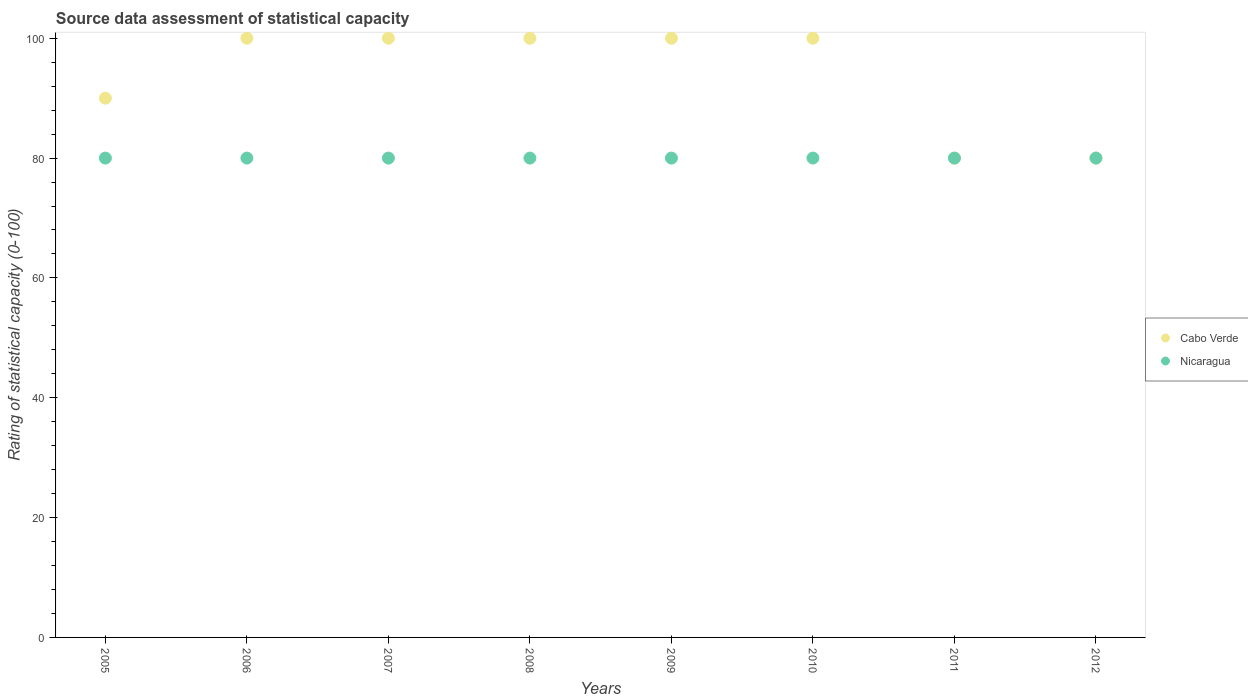Is the number of dotlines equal to the number of legend labels?
Ensure brevity in your answer.  Yes. What is the rating of statistical capacity in Cabo Verde in 2011?
Provide a succinct answer. 80. Across all years, what is the maximum rating of statistical capacity in Nicaragua?
Offer a terse response. 80. Across all years, what is the minimum rating of statistical capacity in Nicaragua?
Keep it short and to the point. 80. What is the total rating of statistical capacity in Cabo Verde in the graph?
Your response must be concise. 750. What is the difference between the rating of statistical capacity in Nicaragua in 2007 and that in 2008?
Keep it short and to the point. 0. What is the difference between the rating of statistical capacity in Nicaragua in 2005 and the rating of statistical capacity in Cabo Verde in 2008?
Make the answer very short. -20. What is the average rating of statistical capacity in Cabo Verde per year?
Offer a very short reply. 93.75. In the year 2007, what is the difference between the rating of statistical capacity in Nicaragua and rating of statistical capacity in Cabo Verde?
Your answer should be compact. -20. In how many years, is the rating of statistical capacity in Nicaragua greater than 28?
Provide a succinct answer. 8. What is the ratio of the rating of statistical capacity in Nicaragua in 2010 to that in 2012?
Give a very brief answer. 1. In how many years, is the rating of statistical capacity in Cabo Verde greater than the average rating of statistical capacity in Cabo Verde taken over all years?
Your response must be concise. 5. Is the sum of the rating of statistical capacity in Cabo Verde in 2008 and 2009 greater than the maximum rating of statistical capacity in Nicaragua across all years?
Your answer should be very brief. Yes. Is the rating of statistical capacity in Nicaragua strictly less than the rating of statistical capacity in Cabo Verde over the years?
Your answer should be very brief. No. How many years are there in the graph?
Your answer should be very brief. 8. What is the difference between two consecutive major ticks on the Y-axis?
Your answer should be compact. 20. Does the graph contain any zero values?
Offer a terse response. No. Does the graph contain grids?
Provide a succinct answer. No. Where does the legend appear in the graph?
Give a very brief answer. Center right. How many legend labels are there?
Offer a very short reply. 2. How are the legend labels stacked?
Give a very brief answer. Vertical. What is the title of the graph?
Provide a short and direct response. Source data assessment of statistical capacity. What is the label or title of the X-axis?
Your answer should be very brief. Years. What is the label or title of the Y-axis?
Give a very brief answer. Rating of statistical capacity (0-100). What is the Rating of statistical capacity (0-100) of Nicaragua in 2005?
Offer a terse response. 80. What is the Rating of statistical capacity (0-100) of Cabo Verde in 2006?
Keep it short and to the point. 100. What is the Rating of statistical capacity (0-100) of Nicaragua in 2007?
Your answer should be very brief. 80. What is the Rating of statistical capacity (0-100) in Nicaragua in 2008?
Your response must be concise. 80. What is the Rating of statistical capacity (0-100) of Nicaragua in 2009?
Provide a succinct answer. 80. What is the Rating of statistical capacity (0-100) of Cabo Verde in 2010?
Give a very brief answer. 100. What is the Rating of statistical capacity (0-100) in Nicaragua in 2010?
Your response must be concise. 80. What is the Rating of statistical capacity (0-100) of Cabo Verde in 2011?
Keep it short and to the point. 80. What is the Rating of statistical capacity (0-100) in Cabo Verde in 2012?
Offer a very short reply. 80. What is the Rating of statistical capacity (0-100) of Nicaragua in 2012?
Offer a very short reply. 80. Across all years, what is the maximum Rating of statistical capacity (0-100) in Cabo Verde?
Make the answer very short. 100. Across all years, what is the maximum Rating of statistical capacity (0-100) in Nicaragua?
Keep it short and to the point. 80. What is the total Rating of statistical capacity (0-100) in Cabo Verde in the graph?
Your response must be concise. 750. What is the total Rating of statistical capacity (0-100) of Nicaragua in the graph?
Ensure brevity in your answer.  640. What is the difference between the Rating of statistical capacity (0-100) in Cabo Verde in 2005 and that in 2006?
Ensure brevity in your answer.  -10. What is the difference between the Rating of statistical capacity (0-100) in Nicaragua in 2005 and that in 2006?
Provide a short and direct response. 0. What is the difference between the Rating of statistical capacity (0-100) of Cabo Verde in 2005 and that in 2007?
Your answer should be compact. -10. What is the difference between the Rating of statistical capacity (0-100) of Nicaragua in 2005 and that in 2008?
Your response must be concise. 0. What is the difference between the Rating of statistical capacity (0-100) in Nicaragua in 2005 and that in 2010?
Ensure brevity in your answer.  0. What is the difference between the Rating of statistical capacity (0-100) in Nicaragua in 2005 and that in 2011?
Provide a short and direct response. 0. What is the difference between the Rating of statistical capacity (0-100) of Cabo Verde in 2005 and that in 2012?
Keep it short and to the point. 10. What is the difference between the Rating of statistical capacity (0-100) in Cabo Verde in 2006 and that in 2008?
Make the answer very short. 0. What is the difference between the Rating of statistical capacity (0-100) in Cabo Verde in 2006 and that in 2009?
Your response must be concise. 0. What is the difference between the Rating of statistical capacity (0-100) of Nicaragua in 2006 and that in 2009?
Keep it short and to the point. 0. What is the difference between the Rating of statistical capacity (0-100) of Cabo Verde in 2006 and that in 2010?
Ensure brevity in your answer.  0. What is the difference between the Rating of statistical capacity (0-100) of Cabo Verde in 2006 and that in 2011?
Offer a very short reply. 20. What is the difference between the Rating of statistical capacity (0-100) in Cabo Verde in 2007 and that in 2011?
Offer a very short reply. 20. What is the difference between the Rating of statistical capacity (0-100) in Nicaragua in 2007 and that in 2011?
Your answer should be very brief. 0. What is the difference between the Rating of statistical capacity (0-100) of Cabo Verde in 2008 and that in 2009?
Offer a terse response. 0. What is the difference between the Rating of statistical capacity (0-100) in Nicaragua in 2008 and that in 2010?
Provide a short and direct response. 0. What is the difference between the Rating of statistical capacity (0-100) of Cabo Verde in 2008 and that in 2011?
Provide a short and direct response. 20. What is the difference between the Rating of statistical capacity (0-100) of Cabo Verde in 2008 and that in 2012?
Offer a very short reply. 20. What is the difference between the Rating of statistical capacity (0-100) of Nicaragua in 2008 and that in 2012?
Offer a very short reply. 0. What is the difference between the Rating of statistical capacity (0-100) in Nicaragua in 2009 and that in 2010?
Offer a very short reply. 0. What is the difference between the Rating of statistical capacity (0-100) in Nicaragua in 2009 and that in 2011?
Make the answer very short. 0. What is the difference between the Rating of statistical capacity (0-100) of Cabo Verde in 2010 and that in 2011?
Keep it short and to the point. 20. What is the difference between the Rating of statistical capacity (0-100) of Cabo Verde in 2010 and that in 2012?
Make the answer very short. 20. What is the difference between the Rating of statistical capacity (0-100) in Nicaragua in 2010 and that in 2012?
Keep it short and to the point. 0. What is the difference between the Rating of statistical capacity (0-100) of Cabo Verde in 2005 and the Rating of statistical capacity (0-100) of Nicaragua in 2007?
Your response must be concise. 10. What is the difference between the Rating of statistical capacity (0-100) in Cabo Verde in 2005 and the Rating of statistical capacity (0-100) in Nicaragua in 2008?
Your response must be concise. 10. What is the difference between the Rating of statistical capacity (0-100) of Cabo Verde in 2005 and the Rating of statistical capacity (0-100) of Nicaragua in 2009?
Provide a succinct answer. 10. What is the difference between the Rating of statistical capacity (0-100) of Cabo Verde in 2006 and the Rating of statistical capacity (0-100) of Nicaragua in 2009?
Keep it short and to the point. 20. What is the difference between the Rating of statistical capacity (0-100) of Cabo Verde in 2006 and the Rating of statistical capacity (0-100) of Nicaragua in 2012?
Provide a succinct answer. 20. What is the difference between the Rating of statistical capacity (0-100) in Cabo Verde in 2007 and the Rating of statistical capacity (0-100) in Nicaragua in 2008?
Your answer should be compact. 20. What is the difference between the Rating of statistical capacity (0-100) in Cabo Verde in 2007 and the Rating of statistical capacity (0-100) in Nicaragua in 2010?
Give a very brief answer. 20. What is the difference between the Rating of statistical capacity (0-100) in Cabo Verde in 2007 and the Rating of statistical capacity (0-100) in Nicaragua in 2012?
Your answer should be very brief. 20. What is the difference between the Rating of statistical capacity (0-100) in Cabo Verde in 2008 and the Rating of statistical capacity (0-100) in Nicaragua in 2012?
Offer a very short reply. 20. What is the difference between the Rating of statistical capacity (0-100) in Cabo Verde in 2009 and the Rating of statistical capacity (0-100) in Nicaragua in 2010?
Your answer should be compact. 20. What is the difference between the Rating of statistical capacity (0-100) in Cabo Verde in 2010 and the Rating of statistical capacity (0-100) in Nicaragua in 2011?
Make the answer very short. 20. What is the difference between the Rating of statistical capacity (0-100) in Cabo Verde in 2011 and the Rating of statistical capacity (0-100) in Nicaragua in 2012?
Make the answer very short. 0. What is the average Rating of statistical capacity (0-100) in Cabo Verde per year?
Keep it short and to the point. 93.75. What is the average Rating of statistical capacity (0-100) of Nicaragua per year?
Provide a succinct answer. 80. In the year 2005, what is the difference between the Rating of statistical capacity (0-100) in Cabo Verde and Rating of statistical capacity (0-100) in Nicaragua?
Your answer should be compact. 10. In the year 2006, what is the difference between the Rating of statistical capacity (0-100) in Cabo Verde and Rating of statistical capacity (0-100) in Nicaragua?
Make the answer very short. 20. In the year 2007, what is the difference between the Rating of statistical capacity (0-100) of Cabo Verde and Rating of statistical capacity (0-100) of Nicaragua?
Your answer should be very brief. 20. In the year 2009, what is the difference between the Rating of statistical capacity (0-100) of Cabo Verde and Rating of statistical capacity (0-100) of Nicaragua?
Give a very brief answer. 20. In the year 2010, what is the difference between the Rating of statistical capacity (0-100) in Cabo Verde and Rating of statistical capacity (0-100) in Nicaragua?
Your answer should be very brief. 20. What is the ratio of the Rating of statistical capacity (0-100) of Nicaragua in 2005 to that in 2007?
Give a very brief answer. 1. What is the ratio of the Rating of statistical capacity (0-100) of Cabo Verde in 2005 to that in 2008?
Provide a short and direct response. 0.9. What is the ratio of the Rating of statistical capacity (0-100) of Cabo Verde in 2005 to that in 2009?
Provide a succinct answer. 0.9. What is the ratio of the Rating of statistical capacity (0-100) in Cabo Verde in 2005 to that in 2010?
Offer a terse response. 0.9. What is the ratio of the Rating of statistical capacity (0-100) in Nicaragua in 2005 to that in 2010?
Offer a terse response. 1. What is the ratio of the Rating of statistical capacity (0-100) of Cabo Verde in 2005 to that in 2011?
Your response must be concise. 1.12. What is the ratio of the Rating of statistical capacity (0-100) of Nicaragua in 2006 to that in 2008?
Provide a short and direct response. 1. What is the ratio of the Rating of statistical capacity (0-100) in Cabo Verde in 2006 to that in 2009?
Offer a terse response. 1. What is the ratio of the Rating of statistical capacity (0-100) in Cabo Verde in 2006 to that in 2012?
Make the answer very short. 1.25. What is the ratio of the Rating of statistical capacity (0-100) of Cabo Verde in 2007 to that in 2008?
Make the answer very short. 1. What is the ratio of the Rating of statistical capacity (0-100) in Nicaragua in 2007 to that in 2008?
Your response must be concise. 1. What is the ratio of the Rating of statistical capacity (0-100) of Nicaragua in 2007 to that in 2009?
Your response must be concise. 1. What is the ratio of the Rating of statistical capacity (0-100) of Cabo Verde in 2007 to that in 2010?
Provide a short and direct response. 1. What is the ratio of the Rating of statistical capacity (0-100) in Nicaragua in 2007 to that in 2010?
Provide a short and direct response. 1. What is the ratio of the Rating of statistical capacity (0-100) in Nicaragua in 2007 to that in 2012?
Your response must be concise. 1. What is the ratio of the Rating of statistical capacity (0-100) in Cabo Verde in 2008 to that in 2009?
Make the answer very short. 1. What is the ratio of the Rating of statistical capacity (0-100) of Nicaragua in 2008 to that in 2009?
Ensure brevity in your answer.  1. What is the ratio of the Rating of statistical capacity (0-100) in Cabo Verde in 2009 to that in 2010?
Keep it short and to the point. 1. What is the ratio of the Rating of statistical capacity (0-100) in Nicaragua in 2009 to that in 2010?
Provide a short and direct response. 1. What is the ratio of the Rating of statistical capacity (0-100) of Cabo Verde in 2009 to that in 2011?
Provide a succinct answer. 1.25. What is the ratio of the Rating of statistical capacity (0-100) in Cabo Verde in 2009 to that in 2012?
Provide a short and direct response. 1.25. What is the ratio of the Rating of statistical capacity (0-100) of Nicaragua in 2009 to that in 2012?
Ensure brevity in your answer.  1. What is the ratio of the Rating of statistical capacity (0-100) of Cabo Verde in 2010 to that in 2011?
Provide a succinct answer. 1.25. What is the ratio of the Rating of statistical capacity (0-100) in Nicaragua in 2010 to that in 2011?
Keep it short and to the point. 1. What is the ratio of the Rating of statistical capacity (0-100) in Cabo Verde in 2010 to that in 2012?
Your response must be concise. 1.25. What is the difference between the highest and the second highest Rating of statistical capacity (0-100) in Cabo Verde?
Make the answer very short. 0. What is the difference between the highest and the lowest Rating of statistical capacity (0-100) in Nicaragua?
Give a very brief answer. 0. 